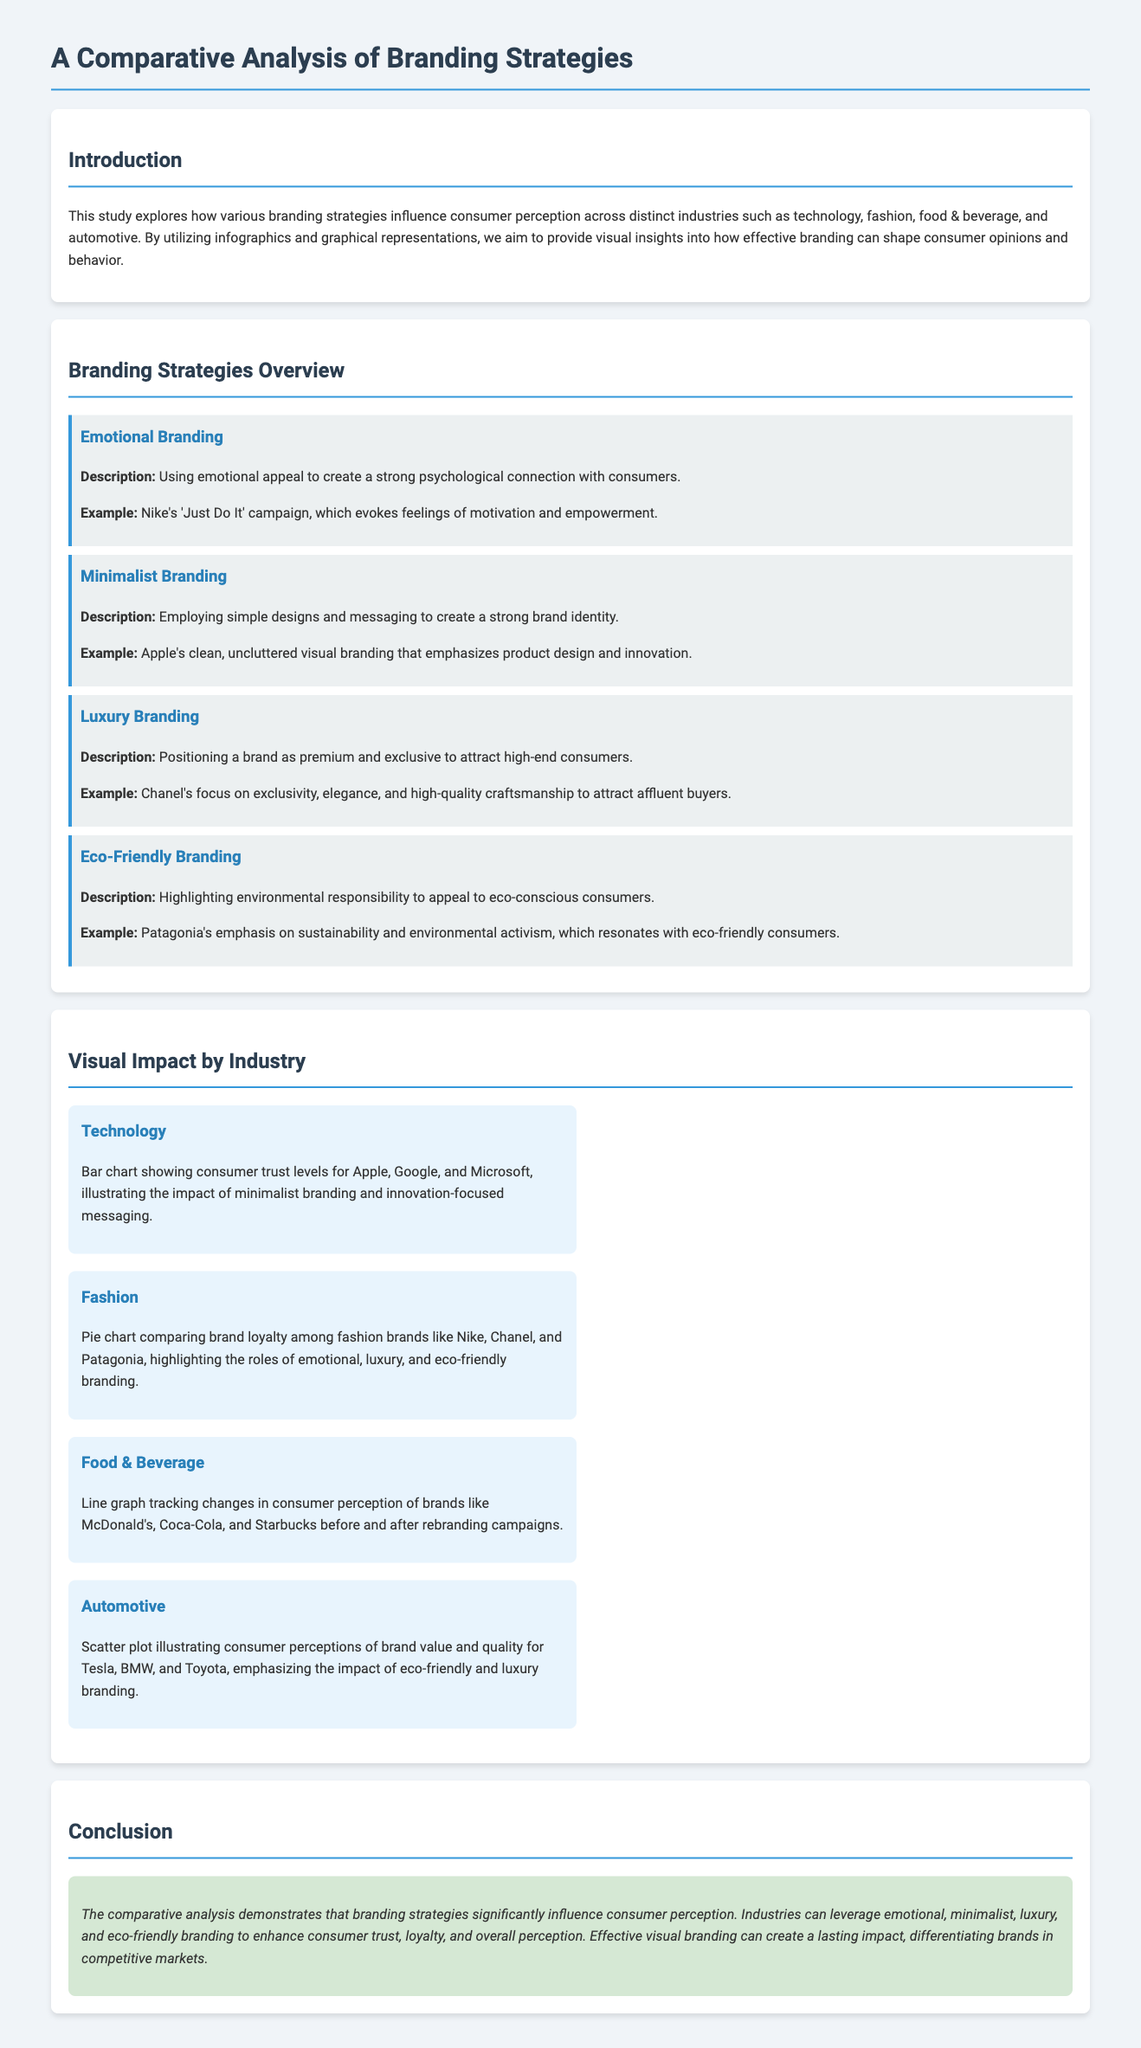What is the title of the document? The title of the document is presented prominently at the top of the page.
Answer: A Comparative Analysis of Branding Strategies Which branding strategy is associated with Nike's 'Just Do It' campaign? The document states that this campaign is an example of emotional branding.
Answer: Emotional Branding What type of chart is used to represent brand loyalty in the fashion industry? The document refers to a pie chart for this representation.
Answer: Pie chart Which branding strategy is highlighted as appealing to eco-conscious consumers? The description conveys that eco-friendly branding is tailored for this audience.
Answer: Eco-Friendly Branding What is the visual representation for technology consumer trust levels? The document specifies that a bar chart is used for this purpose.
Answer: Bar chart In the conclusion, what fundamental aspect do branding strategies influence? The conclusion summarizes the effect of branding strategies on a key element related to consumers.
Answer: Consumer perception Which automotive brand is noted for its eco-friendly branding strategy? The document mentions Tesla as an example under this branding strategy.
Answer: Tesla What does the scatter plot in the automotive section illustrate? It shows a comparison of two specific attributes associated with consumer perceptions.
Answer: Brand value and quality What colors are primarily used in the branding strategies section? The document describes various color choices for visual differentiation in the content.
Answer: Blue and grey 